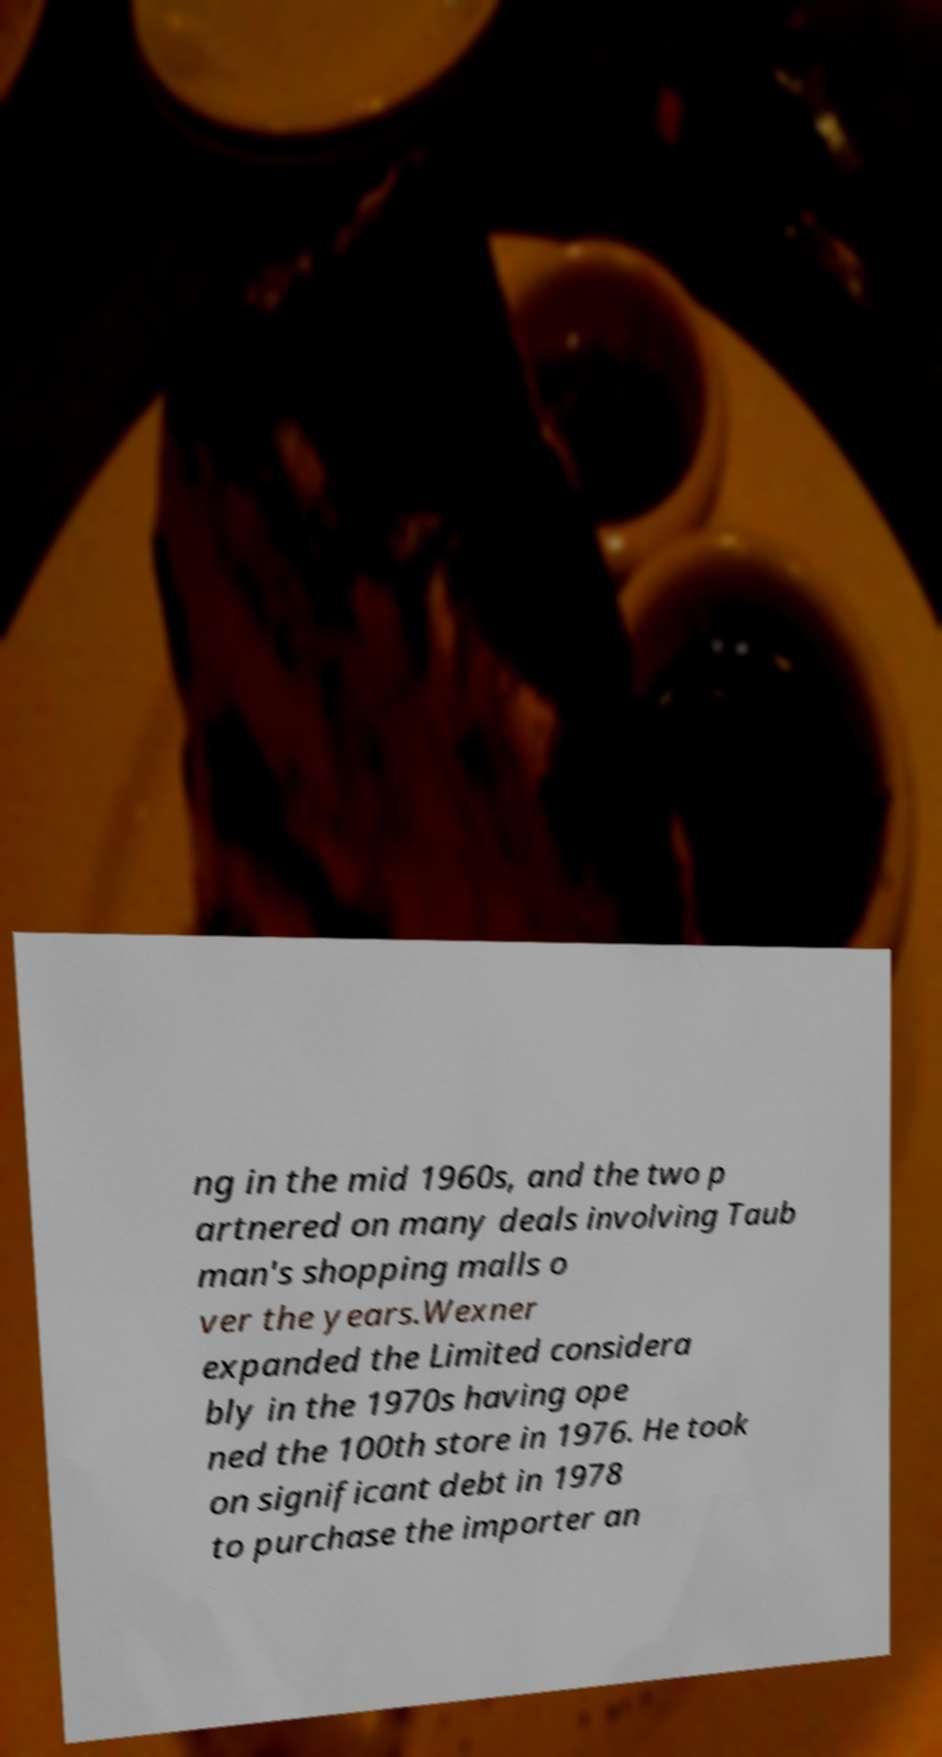Please read and relay the text visible in this image. What does it say? ng in the mid 1960s, and the two p artnered on many deals involving Taub man's shopping malls o ver the years.Wexner expanded the Limited considera bly in the 1970s having ope ned the 100th store in 1976. He took on significant debt in 1978 to purchase the importer an 